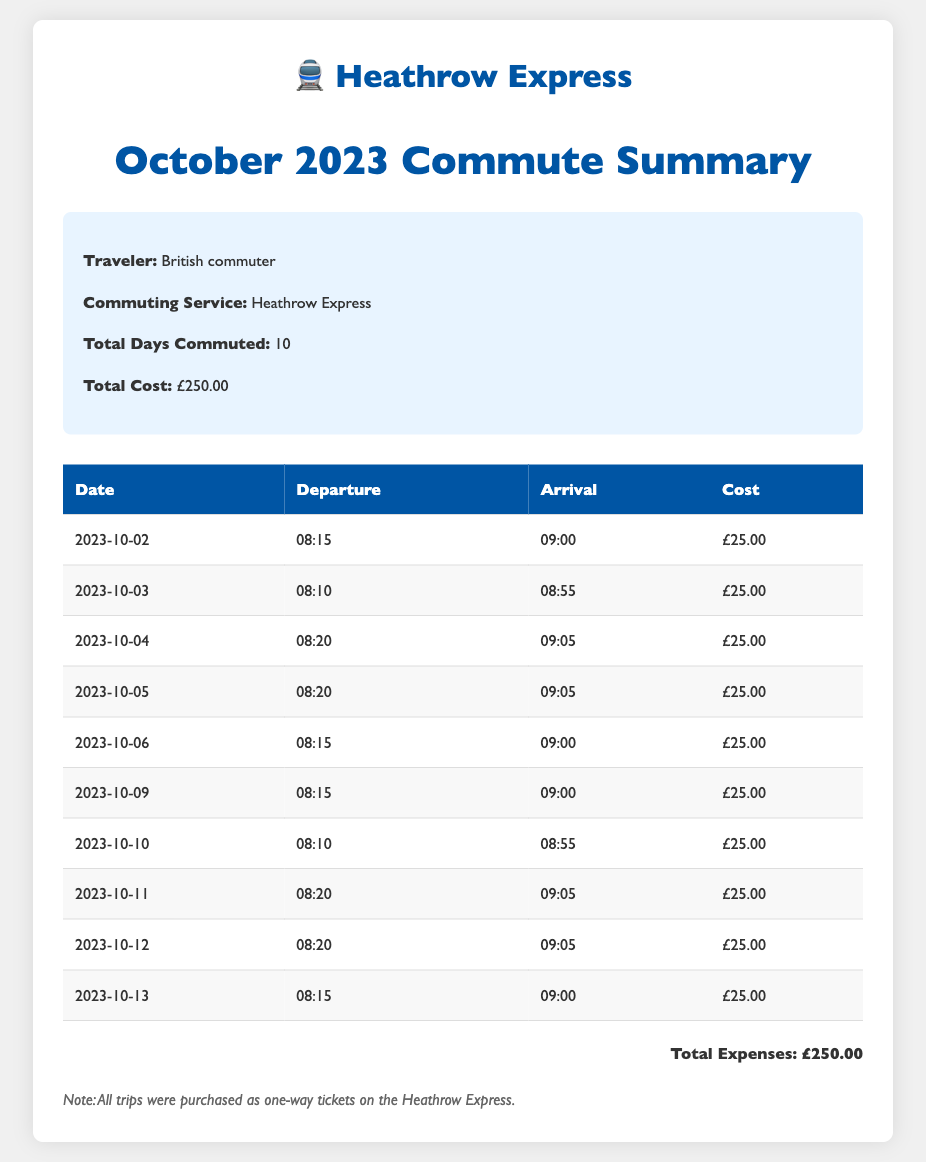What is the total days commuted? The total days commuted is stated in the summary section, which indicates that there were 10 days of commuting for the month.
Answer: 10 What was the total cost of commuting? The total cost is provided in the summary section, which mentions a total of £250.00 for the month.
Answer: £250.00 On which date did the first commute occur? The document lists the travel dates in the table, with the first entry dated 2023-10-02.
Answer: 2023-10-02 What time did the commuter depart on October 3rd? The table shows the departure time for each date, and October 3rd lists a departure time of 08:10.
Answer: 08:10 What was the cost of each commute? From the table, it can be observed that each commute cost £25.00.
Answer: £25.00 What is the average cost per commute? The average cost can be calculated by dividing the total cost by the total days commuted, which is £250.00 divided by 10 days, resulting in £25.00.
Answer: £25.00 How many times did the commuter travel on October 10th? The table shows that there was one entry for October 10th, indicating only one commute on that day.
Answer: 1 What is the color of the heading in the document? The heading color for "October 2023 Commute Summary" is specified as #0055a4, which is a shade of blue.
Answer: Blue What type of tickets were purchased for the commutes? The note at the bottom specifies that all trips were purchased as one-way tickets on the Heathrow Express.
Answer: One-way tickets 